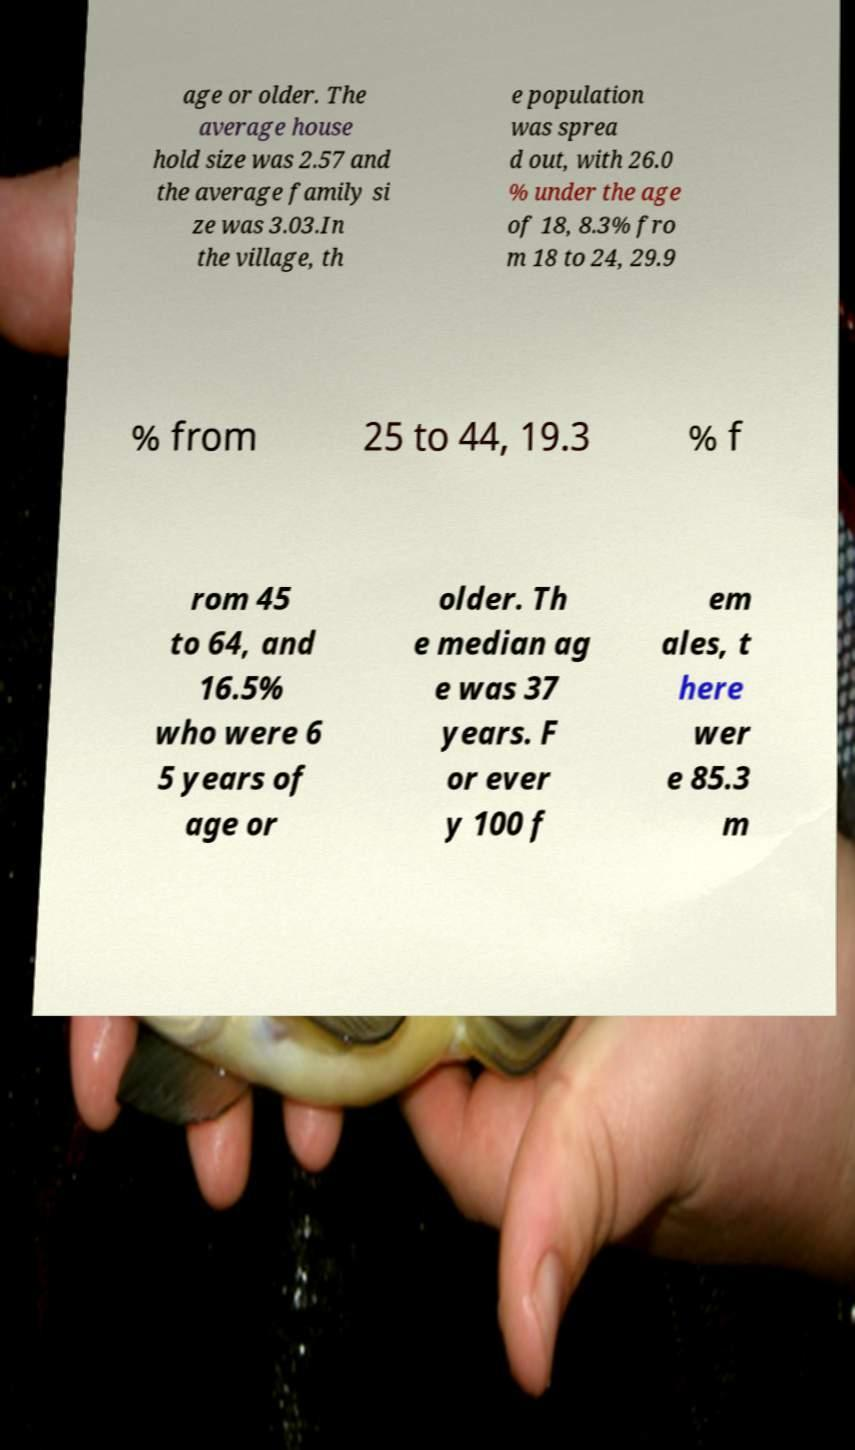Please identify and transcribe the text found in this image. age or older. The average house hold size was 2.57 and the average family si ze was 3.03.In the village, th e population was sprea d out, with 26.0 % under the age of 18, 8.3% fro m 18 to 24, 29.9 % from 25 to 44, 19.3 % f rom 45 to 64, and 16.5% who were 6 5 years of age or older. Th e median ag e was 37 years. F or ever y 100 f em ales, t here wer e 85.3 m 